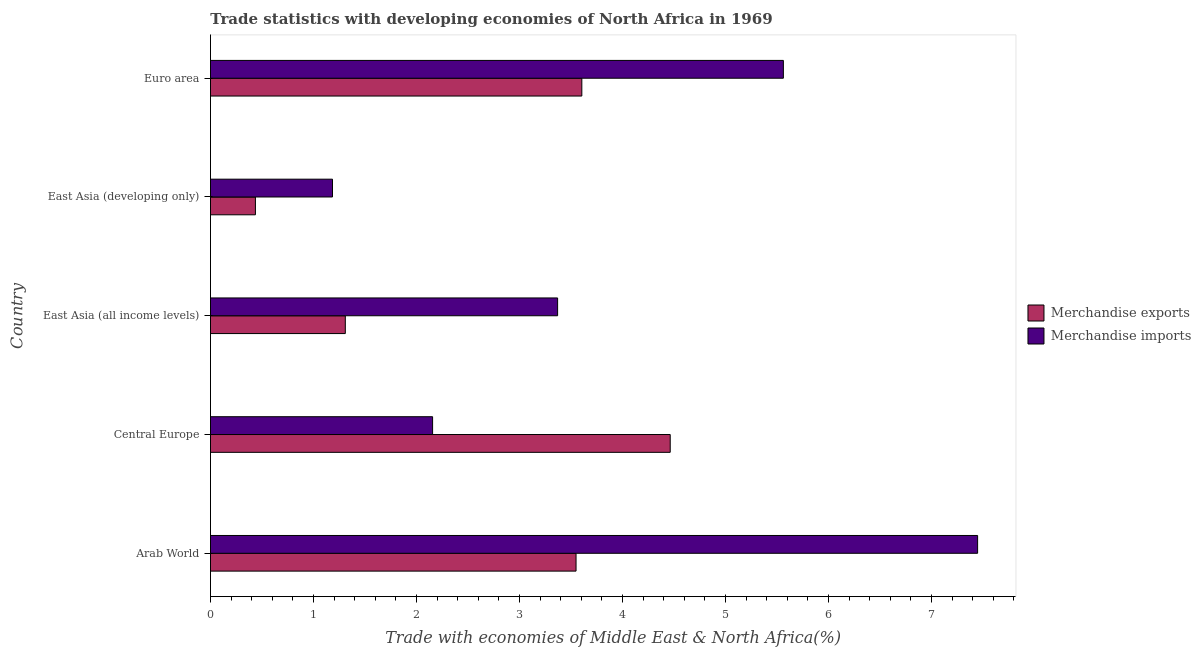How many groups of bars are there?
Provide a short and direct response. 5. Are the number of bars on each tick of the Y-axis equal?
Your answer should be very brief. Yes. How many bars are there on the 3rd tick from the top?
Provide a short and direct response. 2. How many bars are there on the 1st tick from the bottom?
Keep it short and to the point. 2. What is the label of the 4th group of bars from the top?
Offer a terse response. Central Europe. What is the merchandise exports in Arab World?
Give a very brief answer. 3.55. Across all countries, what is the maximum merchandise imports?
Ensure brevity in your answer.  7.45. Across all countries, what is the minimum merchandise imports?
Your response must be concise. 1.18. In which country was the merchandise exports maximum?
Provide a short and direct response. Central Europe. In which country was the merchandise imports minimum?
Provide a succinct answer. East Asia (developing only). What is the total merchandise exports in the graph?
Your answer should be compact. 13.36. What is the difference between the merchandise imports in East Asia (developing only) and that in Euro area?
Offer a very short reply. -4.38. What is the difference between the merchandise imports in East Asia (all income levels) and the merchandise exports in Arab World?
Provide a short and direct response. -0.18. What is the average merchandise exports per country?
Your answer should be compact. 2.67. What is the difference between the merchandise exports and merchandise imports in Euro area?
Keep it short and to the point. -1.96. In how many countries, is the merchandise exports greater than 3 %?
Offer a terse response. 3. What is the ratio of the merchandise imports in East Asia (all income levels) to that in Euro area?
Make the answer very short. 0.61. Is the difference between the merchandise exports in Central Europe and East Asia (developing only) greater than the difference between the merchandise imports in Central Europe and East Asia (developing only)?
Your answer should be very brief. Yes. What is the difference between the highest and the second highest merchandise exports?
Keep it short and to the point. 0.86. What is the difference between the highest and the lowest merchandise imports?
Offer a terse response. 6.26. What does the 2nd bar from the top in Arab World represents?
Provide a succinct answer. Merchandise exports. How many bars are there?
Give a very brief answer. 10. Are all the bars in the graph horizontal?
Provide a succinct answer. Yes. How many countries are there in the graph?
Give a very brief answer. 5. Are the values on the major ticks of X-axis written in scientific E-notation?
Provide a succinct answer. No. Does the graph contain any zero values?
Your answer should be compact. No. How many legend labels are there?
Offer a terse response. 2. What is the title of the graph?
Offer a terse response. Trade statistics with developing economies of North Africa in 1969. What is the label or title of the X-axis?
Provide a succinct answer. Trade with economies of Middle East & North Africa(%). What is the Trade with economies of Middle East & North Africa(%) in Merchandise exports in Arab World?
Your answer should be compact. 3.55. What is the Trade with economies of Middle East & North Africa(%) of Merchandise imports in Arab World?
Make the answer very short. 7.45. What is the Trade with economies of Middle East & North Africa(%) in Merchandise exports in Central Europe?
Your response must be concise. 4.46. What is the Trade with economies of Middle East & North Africa(%) in Merchandise imports in Central Europe?
Your response must be concise. 2.16. What is the Trade with economies of Middle East & North Africa(%) in Merchandise exports in East Asia (all income levels)?
Provide a succinct answer. 1.31. What is the Trade with economies of Middle East & North Africa(%) in Merchandise imports in East Asia (all income levels)?
Keep it short and to the point. 3.37. What is the Trade with economies of Middle East & North Africa(%) in Merchandise exports in East Asia (developing only)?
Your response must be concise. 0.44. What is the Trade with economies of Middle East & North Africa(%) of Merchandise imports in East Asia (developing only)?
Your answer should be very brief. 1.18. What is the Trade with economies of Middle East & North Africa(%) in Merchandise exports in Euro area?
Your answer should be compact. 3.61. What is the Trade with economies of Middle East & North Africa(%) in Merchandise imports in Euro area?
Your answer should be very brief. 5.56. Across all countries, what is the maximum Trade with economies of Middle East & North Africa(%) in Merchandise exports?
Offer a terse response. 4.46. Across all countries, what is the maximum Trade with economies of Middle East & North Africa(%) in Merchandise imports?
Keep it short and to the point. 7.45. Across all countries, what is the minimum Trade with economies of Middle East & North Africa(%) in Merchandise exports?
Make the answer very short. 0.44. Across all countries, what is the minimum Trade with economies of Middle East & North Africa(%) in Merchandise imports?
Provide a short and direct response. 1.18. What is the total Trade with economies of Middle East & North Africa(%) of Merchandise exports in the graph?
Make the answer very short. 13.36. What is the total Trade with economies of Middle East & North Africa(%) of Merchandise imports in the graph?
Offer a very short reply. 19.72. What is the difference between the Trade with economies of Middle East & North Africa(%) in Merchandise exports in Arab World and that in Central Europe?
Your response must be concise. -0.91. What is the difference between the Trade with economies of Middle East & North Africa(%) of Merchandise imports in Arab World and that in Central Europe?
Provide a succinct answer. 5.29. What is the difference between the Trade with economies of Middle East & North Africa(%) in Merchandise exports in Arab World and that in East Asia (all income levels)?
Your response must be concise. 2.24. What is the difference between the Trade with economies of Middle East & North Africa(%) of Merchandise imports in Arab World and that in East Asia (all income levels)?
Offer a very short reply. 4.08. What is the difference between the Trade with economies of Middle East & North Africa(%) in Merchandise exports in Arab World and that in East Asia (developing only)?
Ensure brevity in your answer.  3.11. What is the difference between the Trade with economies of Middle East & North Africa(%) of Merchandise imports in Arab World and that in East Asia (developing only)?
Your answer should be very brief. 6.26. What is the difference between the Trade with economies of Middle East & North Africa(%) in Merchandise exports in Arab World and that in Euro area?
Give a very brief answer. -0.06. What is the difference between the Trade with economies of Middle East & North Africa(%) of Merchandise imports in Arab World and that in Euro area?
Keep it short and to the point. 1.89. What is the difference between the Trade with economies of Middle East & North Africa(%) of Merchandise exports in Central Europe and that in East Asia (all income levels)?
Offer a terse response. 3.15. What is the difference between the Trade with economies of Middle East & North Africa(%) in Merchandise imports in Central Europe and that in East Asia (all income levels)?
Your answer should be compact. -1.21. What is the difference between the Trade with economies of Middle East & North Africa(%) of Merchandise exports in Central Europe and that in East Asia (developing only)?
Keep it short and to the point. 4.03. What is the difference between the Trade with economies of Middle East & North Africa(%) of Merchandise imports in Central Europe and that in East Asia (developing only)?
Offer a very short reply. 0.97. What is the difference between the Trade with economies of Middle East & North Africa(%) in Merchandise exports in Central Europe and that in Euro area?
Offer a terse response. 0.86. What is the difference between the Trade with economies of Middle East & North Africa(%) in Merchandise imports in Central Europe and that in Euro area?
Keep it short and to the point. -3.41. What is the difference between the Trade with economies of Middle East & North Africa(%) of Merchandise exports in East Asia (all income levels) and that in East Asia (developing only)?
Provide a succinct answer. 0.87. What is the difference between the Trade with economies of Middle East & North Africa(%) of Merchandise imports in East Asia (all income levels) and that in East Asia (developing only)?
Offer a very short reply. 2.19. What is the difference between the Trade with economies of Middle East & North Africa(%) in Merchandise exports in East Asia (all income levels) and that in Euro area?
Your answer should be very brief. -2.3. What is the difference between the Trade with economies of Middle East & North Africa(%) in Merchandise imports in East Asia (all income levels) and that in Euro area?
Keep it short and to the point. -2.19. What is the difference between the Trade with economies of Middle East & North Africa(%) of Merchandise exports in East Asia (developing only) and that in Euro area?
Your answer should be compact. -3.17. What is the difference between the Trade with economies of Middle East & North Africa(%) in Merchandise imports in East Asia (developing only) and that in Euro area?
Provide a succinct answer. -4.38. What is the difference between the Trade with economies of Middle East & North Africa(%) in Merchandise exports in Arab World and the Trade with economies of Middle East & North Africa(%) in Merchandise imports in Central Europe?
Ensure brevity in your answer.  1.39. What is the difference between the Trade with economies of Middle East & North Africa(%) of Merchandise exports in Arab World and the Trade with economies of Middle East & North Africa(%) of Merchandise imports in East Asia (all income levels)?
Offer a terse response. 0.18. What is the difference between the Trade with economies of Middle East & North Africa(%) of Merchandise exports in Arab World and the Trade with economies of Middle East & North Africa(%) of Merchandise imports in East Asia (developing only)?
Your answer should be compact. 2.36. What is the difference between the Trade with economies of Middle East & North Africa(%) of Merchandise exports in Arab World and the Trade with economies of Middle East & North Africa(%) of Merchandise imports in Euro area?
Offer a terse response. -2.01. What is the difference between the Trade with economies of Middle East & North Africa(%) in Merchandise exports in Central Europe and the Trade with economies of Middle East & North Africa(%) in Merchandise imports in East Asia (all income levels)?
Your response must be concise. 1.09. What is the difference between the Trade with economies of Middle East & North Africa(%) in Merchandise exports in Central Europe and the Trade with economies of Middle East & North Africa(%) in Merchandise imports in East Asia (developing only)?
Offer a terse response. 3.28. What is the difference between the Trade with economies of Middle East & North Africa(%) in Merchandise exports in Central Europe and the Trade with economies of Middle East & North Africa(%) in Merchandise imports in Euro area?
Ensure brevity in your answer.  -1.1. What is the difference between the Trade with economies of Middle East & North Africa(%) in Merchandise exports in East Asia (all income levels) and the Trade with economies of Middle East & North Africa(%) in Merchandise imports in East Asia (developing only)?
Give a very brief answer. 0.12. What is the difference between the Trade with economies of Middle East & North Africa(%) of Merchandise exports in East Asia (all income levels) and the Trade with economies of Middle East & North Africa(%) of Merchandise imports in Euro area?
Provide a succinct answer. -4.25. What is the difference between the Trade with economies of Middle East & North Africa(%) in Merchandise exports in East Asia (developing only) and the Trade with economies of Middle East & North Africa(%) in Merchandise imports in Euro area?
Give a very brief answer. -5.13. What is the average Trade with economies of Middle East & North Africa(%) of Merchandise exports per country?
Offer a terse response. 2.67. What is the average Trade with economies of Middle East & North Africa(%) in Merchandise imports per country?
Keep it short and to the point. 3.94. What is the difference between the Trade with economies of Middle East & North Africa(%) of Merchandise exports and Trade with economies of Middle East & North Africa(%) of Merchandise imports in Arab World?
Your answer should be compact. -3.9. What is the difference between the Trade with economies of Middle East & North Africa(%) of Merchandise exports and Trade with economies of Middle East & North Africa(%) of Merchandise imports in Central Europe?
Offer a very short reply. 2.31. What is the difference between the Trade with economies of Middle East & North Africa(%) of Merchandise exports and Trade with economies of Middle East & North Africa(%) of Merchandise imports in East Asia (all income levels)?
Offer a terse response. -2.06. What is the difference between the Trade with economies of Middle East & North Africa(%) in Merchandise exports and Trade with economies of Middle East & North Africa(%) in Merchandise imports in East Asia (developing only)?
Offer a terse response. -0.75. What is the difference between the Trade with economies of Middle East & North Africa(%) in Merchandise exports and Trade with economies of Middle East & North Africa(%) in Merchandise imports in Euro area?
Your answer should be very brief. -1.96. What is the ratio of the Trade with economies of Middle East & North Africa(%) in Merchandise exports in Arab World to that in Central Europe?
Make the answer very short. 0.8. What is the ratio of the Trade with economies of Middle East & North Africa(%) in Merchandise imports in Arab World to that in Central Europe?
Provide a succinct answer. 3.45. What is the ratio of the Trade with economies of Middle East & North Africa(%) in Merchandise exports in Arab World to that in East Asia (all income levels)?
Your answer should be compact. 2.71. What is the ratio of the Trade with economies of Middle East & North Africa(%) of Merchandise imports in Arab World to that in East Asia (all income levels)?
Offer a very short reply. 2.21. What is the ratio of the Trade with economies of Middle East & North Africa(%) in Merchandise exports in Arab World to that in East Asia (developing only)?
Provide a succinct answer. 8.13. What is the ratio of the Trade with economies of Middle East & North Africa(%) of Merchandise imports in Arab World to that in East Asia (developing only)?
Your answer should be compact. 6.29. What is the ratio of the Trade with economies of Middle East & North Africa(%) in Merchandise exports in Arab World to that in Euro area?
Offer a terse response. 0.98. What is the ratio of the Trade with economies of Middle East & North Africa(%) of Merchandise imports in Arab World to that in Euro area?
Your answer should be compact. 1.34. What is the ratio of the Trade with economies of Middle East & North Africa(%) of Merchandise exports in Central Europe to that in East Asia (all income levels)?
Provide a short and direct response. 3.41. What is the ratio of the Trade with economies of Middle East & North Africa(%) in Merchandise imports in Central Europe to that in East Asia (all income levels)?
Ensure brevity in your answer.  0.64. What is the ratio of the Trade with economies of Middle East & North Africa(%) in Merchandise exports in Central Europe to that in East Asia (developing only)?
Your response must be concise. 10.23. What is the ratio of the Trade with economies of Middle East & North Africa(%) of Merchandise imports in Central Europe to that in East Asia (developing only)?
Offer a very short reply. 1.82. What is the ratio of the Trade with economies of Middle East & North Africa(%) in Merchandise exports in Central Europe to that in Euro area?
Offer a very short reply. 1.24. What is the ratio of the Trade with economies of Middle East & North Africa(%) in Merchandise imports in Central Europe to that in Euro area?
Your answer should be very brief. 0.39. What is the ratio of the Trade with economies of Middle East & North Africa(%) of Merchandise exports in East Asia (all income levels) to that in East Asia (developing only)?
Keep it short and to the point. 3. What is the ratio of the Trade with economies of Middle East & North Africa(%) in Merchandise imports in East Asia (all income levels) to that in East Asia (developing only)?
Your response must be concise. 2.84. What is the ratio of the Trade with economies of Middle East & North Africa(%) in Merchandise exports in East Asia (all income levels) to that in Euro area?
Your answer should be very brief. 0.36. What is the ratio of the Trade with economies of Middle East & North Africa(%) of Merchandise imports in East Asia (all income levels) to that in Euro area?
Keep it short and to the point. 0.61. What is the ratio of the Trade with economies of Middle East & North Africa(%) of Merchandise exports in East Asia (developing only) to that in Euro area?
Ensure brevity in your answer.  0.12. What is the ratio of the Trade with economies of Middle East & North Africa(%) in Merchandise imports in East Asia (developing only) to that in Euro area?
Make the answer very short. 0.21. What is the difference between the highest and the second highest Trade with economies of Middle East & North Africa(%) of Merchandise exports?
Your response must be concise. 0.86. What is the difference between the highest and the second highest Trade with economies of Middle East & North Africa(%) in Merchandise imports?
Provide a succinct answer. 1.89. What is the difference between the highest and the lowest Trade with economies of Middle East & North Africa(%) of Merchandise exports?
Your answer should be very brief. 4.03. What is the difference between the highest and the lowest Trade with economies of Middle East & North Africa(%) in Merchandise imports?
Your answer should be compact. 6.26. 